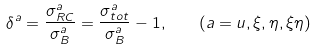Convert formula to latex. <formula><loc_0><loc_0><loc_500><loc_500>\delta ^ { a } = \frac { \sigma _ { R C } ^ { a } } { \sigma _ { B } ^ { a } } = \frac { \sigma _ { t o t } ^ { a } } { \sigma _ { B } ^ { a } } - 1 , \quad ( a = u , \xi , \eta , \xi \eta )</formula> 